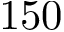Convert formula to latex. <formula><loc_0><loc_0><loc_500><loc_500>1 5 0</formula> 